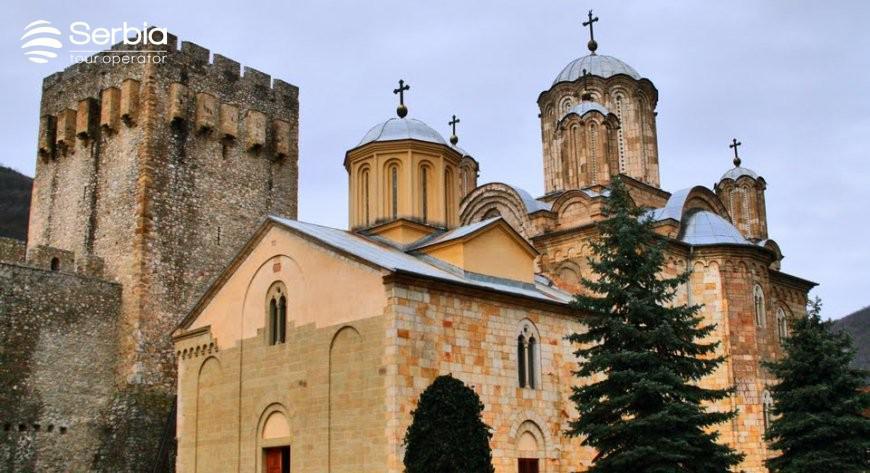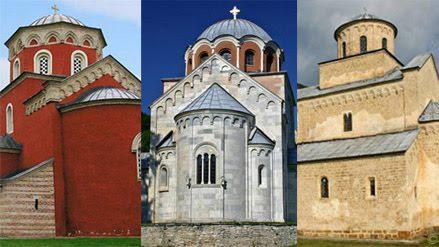The first image is the image on the left, the second image is the image on the right. Given the left and right images, does the statement "An image shows a tall building with a flat top that is notched like a castle." hold true? Answer yes or no. Yes. 